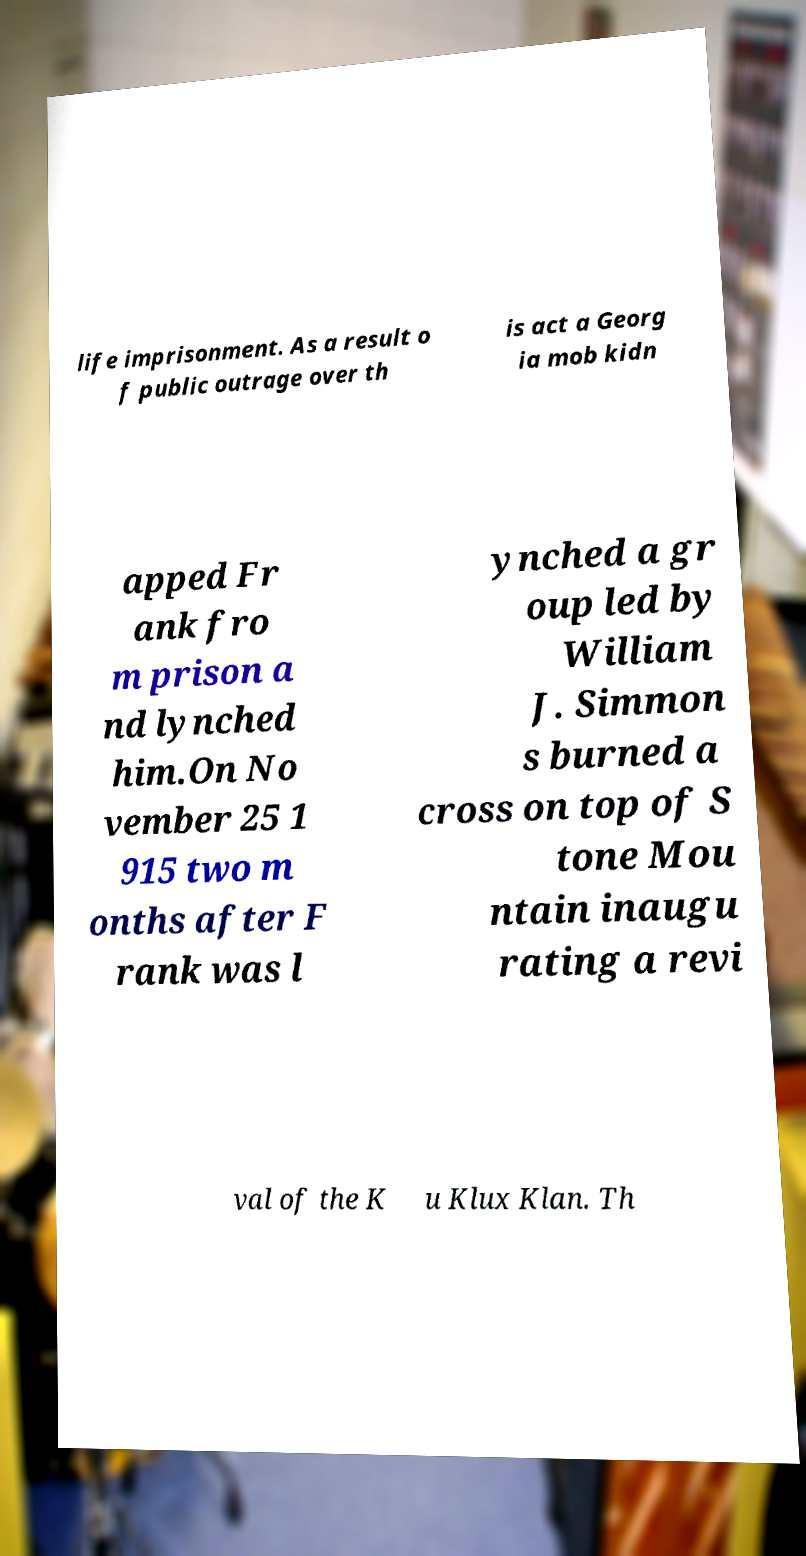Could you assist in decoding the text presented in this image and type it out clearly? life imprisonment. As a result o f public outrage over th is act a Georg ia mob kidn apped Fr ank fro m prison a nd lynched him.On No vember 25 1 915 two m onths after F rank was l ynched a gr oup led by William J. Simmon s burned a cross on top of S tone Mou ntain inaugu rating a revi val of the K u Klux Klan. Th 